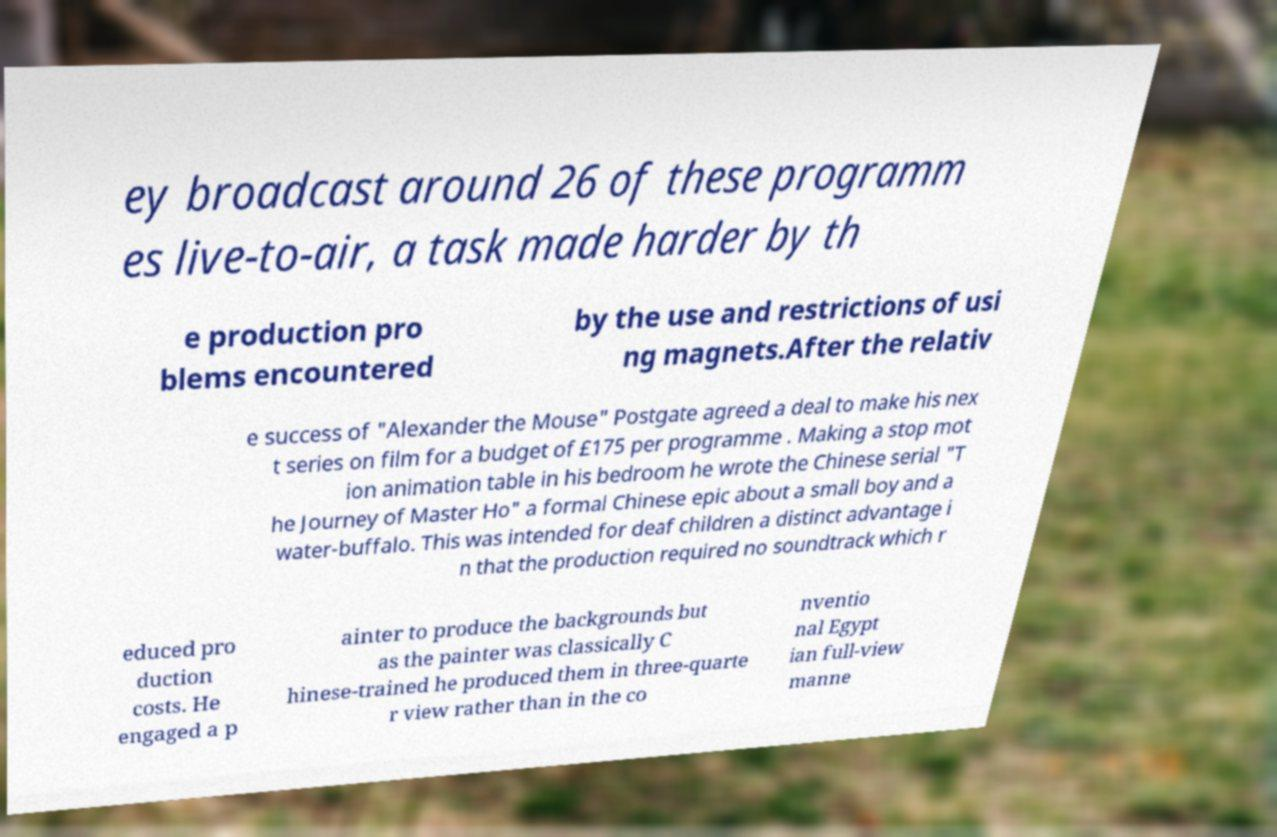For documentation purposes, I need the text within this image transcribed. Could you provide that? ey broadcast around 26 of these programm es live-to-air, a task made harder by th e production pro blems encountered by the use and restrictions of usi ng magnets.After the relativ e success of "Alexander the Mouse" Postgate agreed a deal to make his nex t series on film for a budget of £175 per programme . Making a stop mot ion animation table in his bedroom he wrote the Chinese serial "T he Journey of Master Ho" a formal Chinese epic about a small boy and a water-buffalo. This was intended for deaf children a distinct advantage i n that the production required no soundtrack which r educed pro duction costs. He engaged a p ainter to produce the backgrounds but as the painter was classically C hinese-trained he produced them in three-quarte r view rather than in the co nventio nal Egypt ian full-view manne 